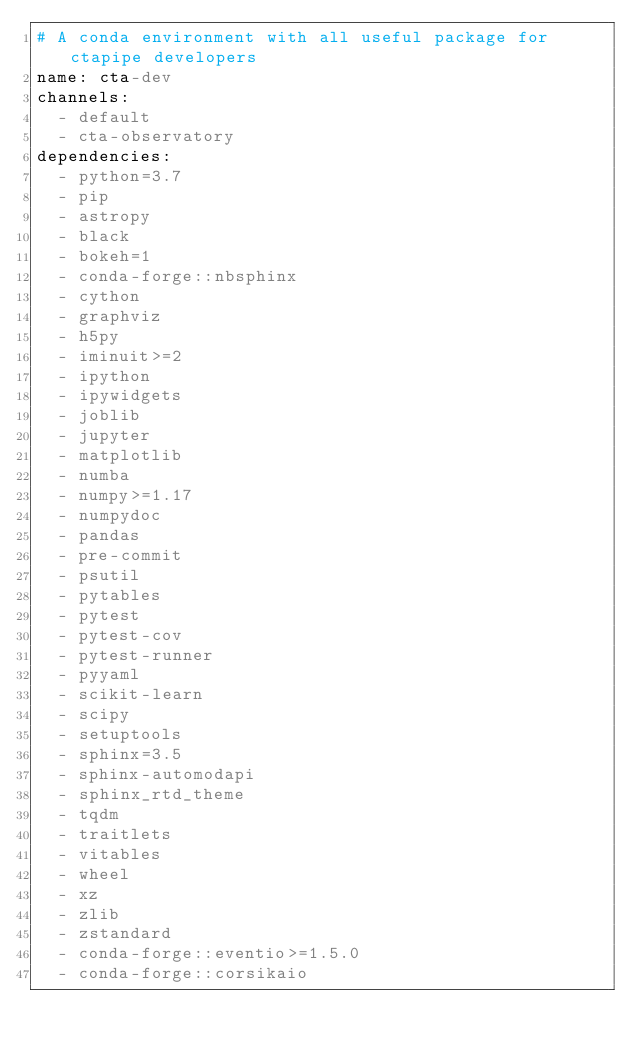<code> <loc_0><loc_0><loc_500><loc_500><_YAML_># A conda environment with all useful package for ctapipe developers
name: cta-dev
channels:
  - default
  - cta-observatory
dependencies:
  - python=3.7
  - pip
  - astropy
  - black
  - bokeh=1
  - conda-forge::nbsphinx
  - cython
  - graphviz
  - h5py
  - iminuit>=2
  - ipython
  - ipywidgets
  - joblib
  - jupyter
  - matplotlib
  - numba
  - numpy>=1.17
  - numpydoc
  - pandas
  - pre-commit
  - psutil
  - pytables
  - pytest
  - pytest-cov
  - pytest-runner
  - pyyaml
  - scikit-learn
  - scipy
  - setuptools
  - sphinx=3.5
  - sphinx-automodapi
  - sphinx_rtd_theme
  - tqdm
  - traitlets
  - vitables
  - wheel
  - xz
  - zlib
  - zstandard
  - conda-forge::eventio>=1.5.0
  - conda-forge::corsikaio
</code> 